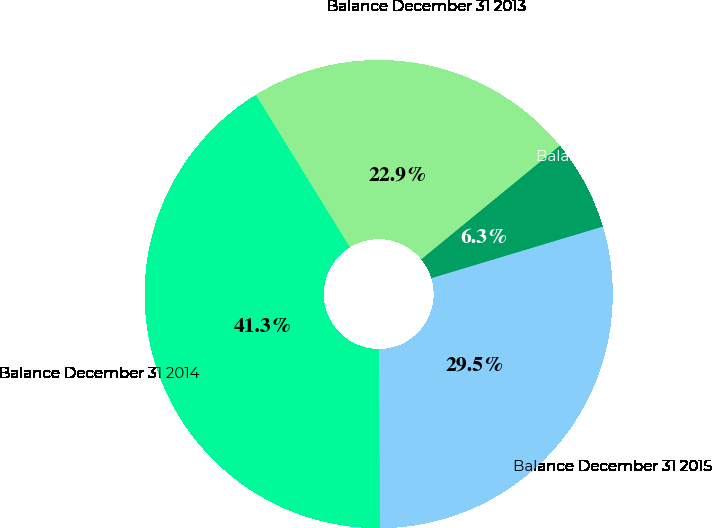Convert chart to OTSL. <chart><loc_0><loc_0><loc_500><loc_500><pie_chart><fcel>Balance December 31 2012<fcel>Balance December 31 2013<fcel>Balance December 31 2014<fcel>Balance December 31 2015<nl><fcel>6.28%<fcel>22.87%<fcel>41.3%<fcel>29.55%<nl></chart> 